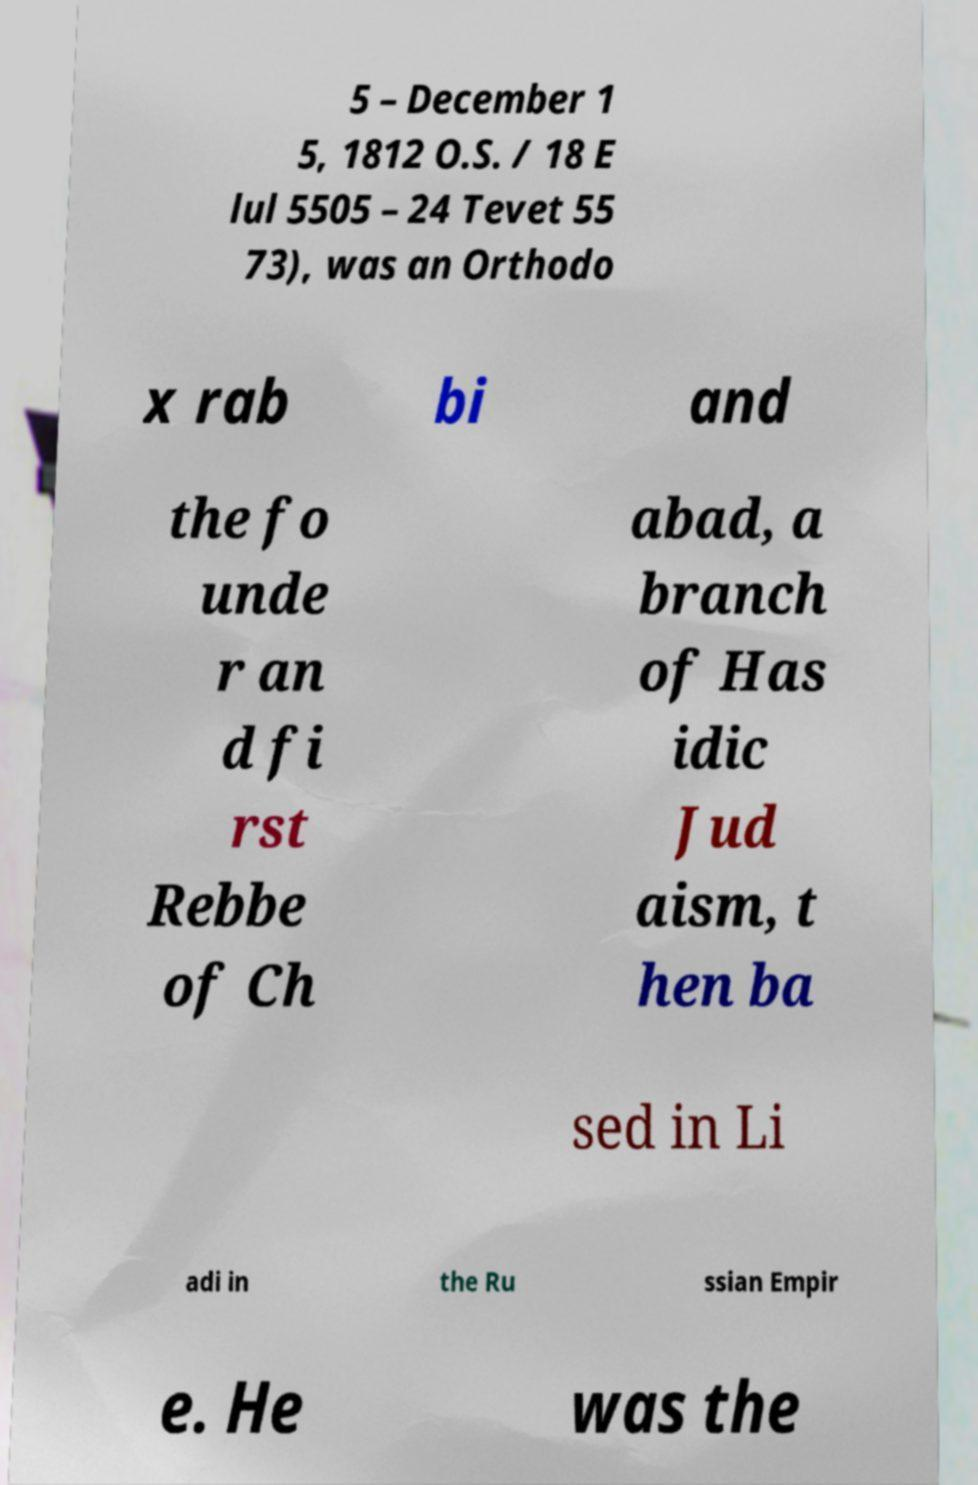I need the written content from this picture converted into text. Can you do that? 5 – December 1 5, 1812 O.S. / 18 E lul 5505 – 24 Tevet 55 73), was an Orthodo x rab bi and the fo unde r an d fi rst Rebbe of Ch abad, a branch of Has idic Jud aism, t hen ba sed in Li adi in the Ru ssian Empir e. He was the 